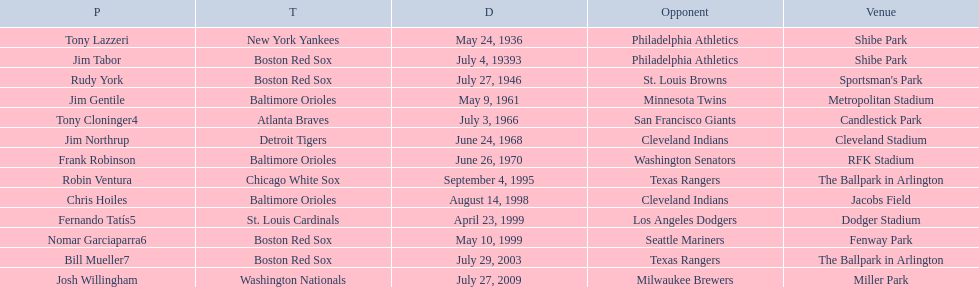Who were all the teams? New York Yankees, Boston Red Sox, Boston Red Sox, Baltimore Orioles, Atlanta Braves, Detroit Tigers, Baltimore Orioles, Chicago White Sox, Baltimore Orioles, St. Louis Cardinals, Boston Red Sox, Boston Red Sox, Washington Nationals. What about opponents? Philadelphia Athletics, Philadelphia Athletics, St. Louis Browns, Minnesota Twins, San Francisco Giants, Cleveland Indians, Washington Senators, Texas Rangers, Cleveland Indians, Los Angeles Dodgers, Seattle Mariners, Texas Rangers, Milwaukee Brewers. And when did they play? May 24, 1936, July 4, 19393, July 27, 1946, May 9, 1961, July 3, 1966, June 24, 1968, June 26, 1970, September 4, 1995, August 14, 1998, April 23, 1999, May 10, 1999, July 29, 2003, July 27, 2009. Which team played the red sox on july 27, 1946	? St. Louis Browns. 